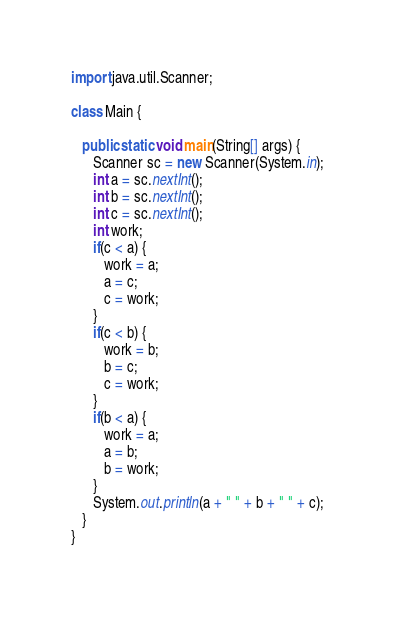<code> <loc_0><loc_0><loc_500><loc_500><_Java_>import java.util.Scanner;

class Main {

   public static void main(String[] args) {
      Scanner sc = new Scanner(System.in);
      int a = sc.nextInt();
      int b = sc.nextInt();
      int c = sc.nextInt();
      int work;
      if(c < a) {
         work = a;
         a = c;
         c = work;
      }
      if(c < b) {
         work = b;
         b = c;
         c = work;
      }
      if(b < a) {
         work = a;
         a = b;
         b = work;
      }
      System.out.println(a + " " + b + " " + c);
   }
}</code> 